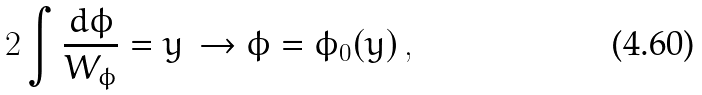Convert formula to latex. <formula><loc_0><loc_0><loc_500><loc_500>2 \int \frac { d \phi } { W _ { \phi } } = y \, \to \phi = \phi _ { 0 } ( y ) \, ,</formula> 